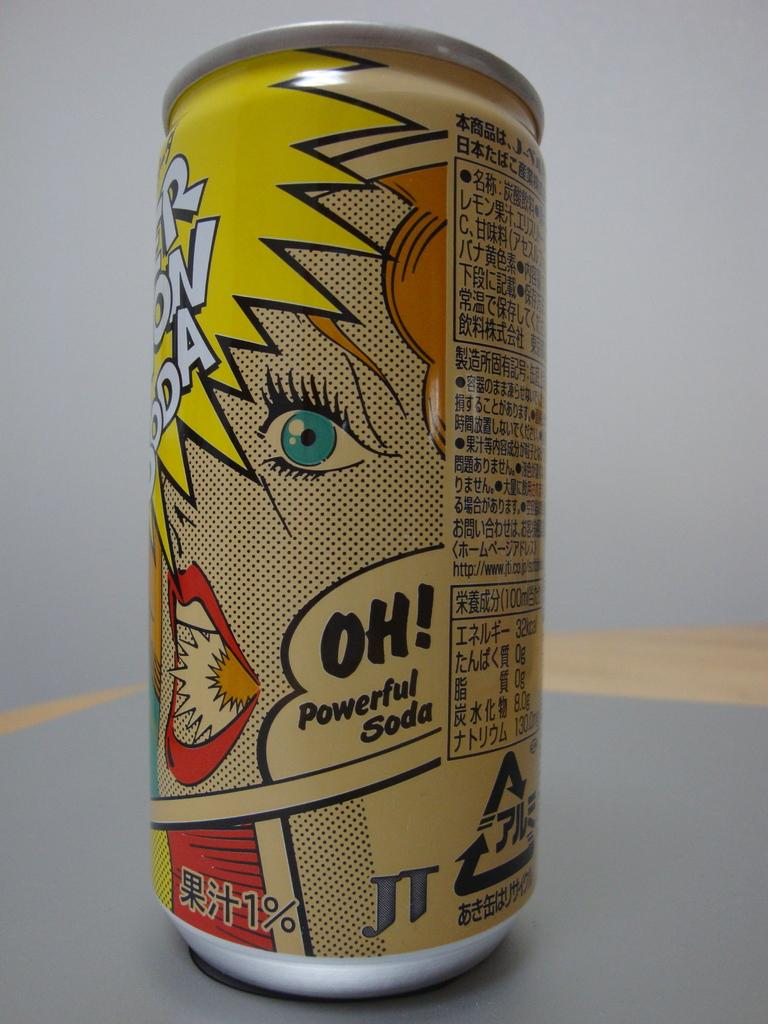<image>
Write a terse but informative summary of the picture. the word oh is on a can on a gray surface 